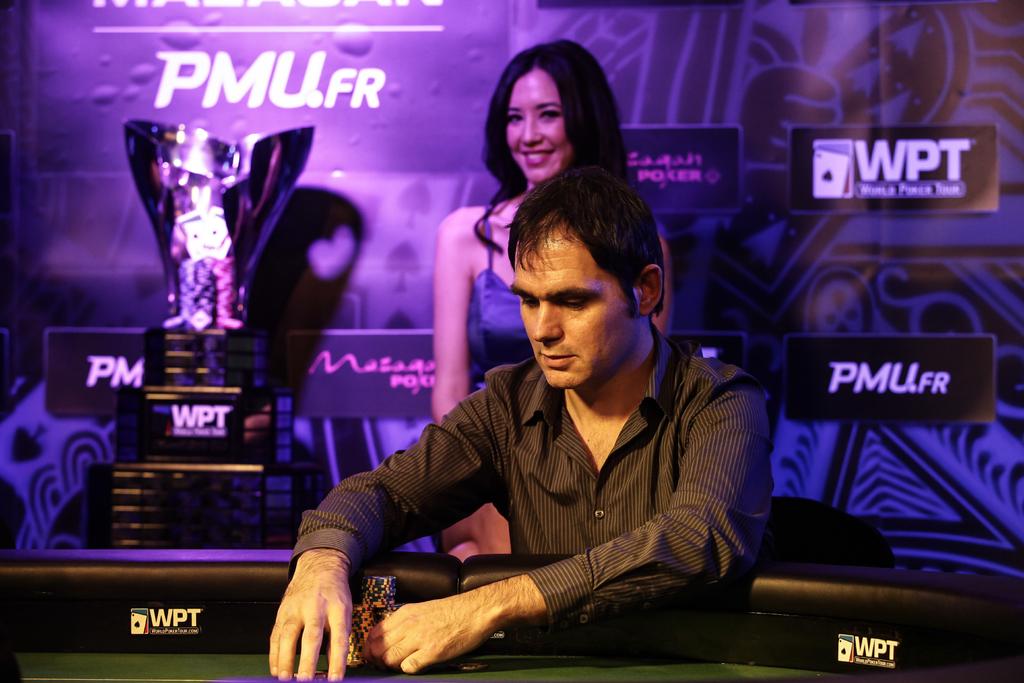What tournament is being held here?
Make the answer very short. Poker. 